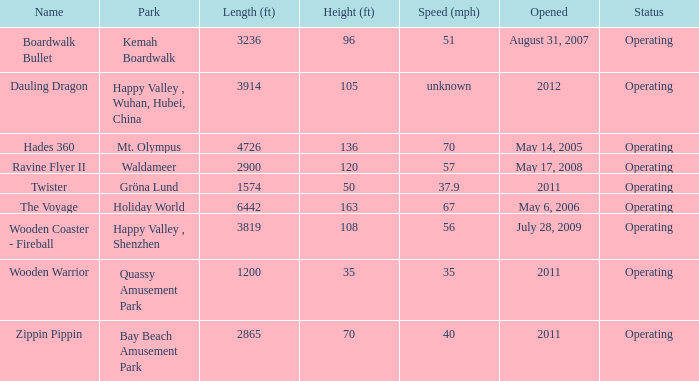How many parks are called mt. olympus 1.0. Write the full table. {'header': ['Name', 'Park', 'Length (ft)', 'Height (ft)', 'Speed (mph)', 'Opened', 'Status'], 'rows': [['Boardwalk Bullet', 'Kemah Boardwalk', '3236', '96', '51', 'August 31, 2007', 'Operating'], ['Dauling Dragon', 'Happy Valley , Wuhan, Hubei, China', '3914', '105', 'unknown', '2012', 'Operating'], ['Hades 360', 'Mt. Olympus', '4726', '136', '70', 'May 14, 2005', 'Operating'], ['Ravine Flyer II', 'Waldameer', '2900', '120', '57', 'May 17, 2008', 'Operating'], ['Twister', 'Gröna Lund', '1574', '50', '37.9', '2011', 'Operating'], ['The Voyage', 'Holiday World', '6442', '163', '67', 'May 6, 2006', 'Operating'], ['Wooden Coaster - Fireball', 'Happy Valley , Shenzhen', '3819', '108', '56', 'July 28, 2009', 'Operating'], ['Wooden Warrior', 'Quassy Amusement Park', '1200', '35', '35', '2011', 'Operating'], ['Zippin Pippin', 'Bay Beach Amusement Park', '2865', '70', '40', '2011', 'Operating']]} 